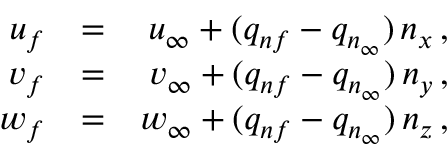Convert formula to latex. <formula><loc_0><loc_0><loc_500><loc_500>\begin{array} { r l r } { { u _ { f } } } & { = } & { { u _ { \infty } + ( q _ { n f } - q _ { n _ { \infty } } ) \, n _ { x } \, , } } \\ { { v _ { f } } } & { = } & { { v _ { \infty } + ( q _ { n f } - q _ { n _ { \infty } } ) \, n _ { y } \, , } } \\ { { w _ { f } } } & { = } & { { w _ { \infty } + ( q _ { n f } - q _ { n _ { \infty } } ) \, n _ { z } \, , } } \end{array}</formula> 